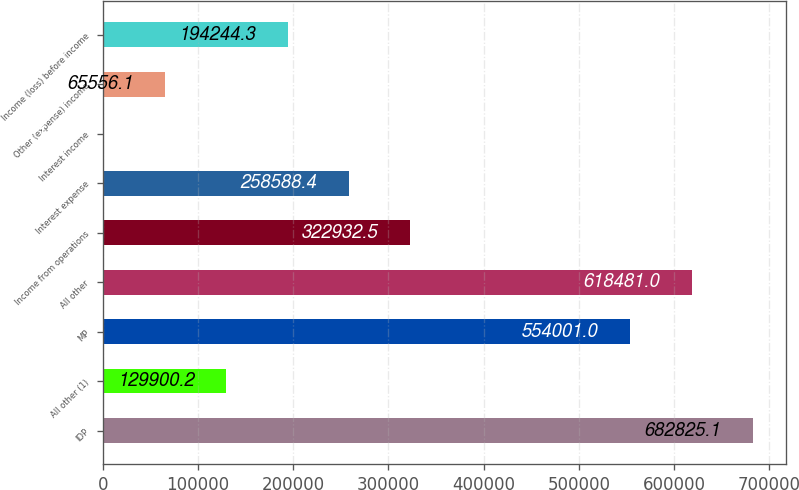<chart> <loc_0><loc_0><loc_500><loc_500><bar_chart><fcel>IDP<fcel>All other (1)<fcel>MP<fcel>All other<fcel>Income from operations<fcel>Interest expense<fcel>Interest income<fcel>Other (expense) income<fcel>Income (loss) before income<nl><fcel>682825<fcel>129900<fcel>554001<fcel>618481<fcel>322932<fcel>258588<fcel>1212<fcel>65556.1<fcel>194244<nl></chart> 